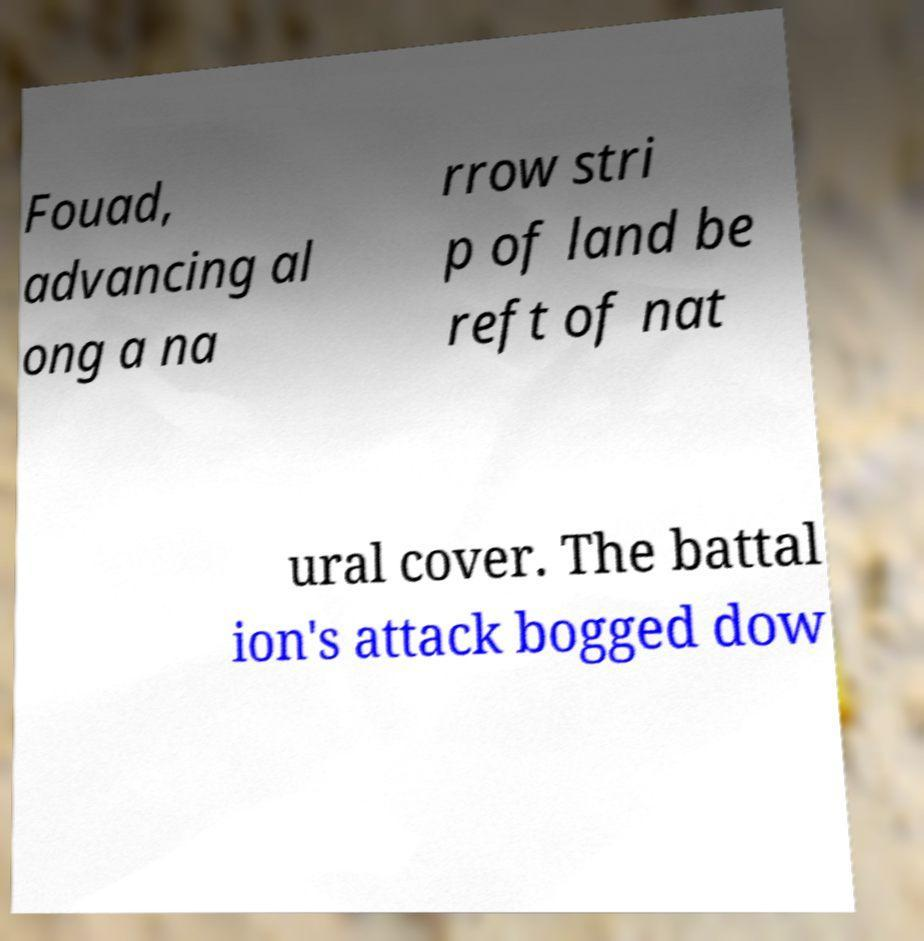Could you extract and type out the text from this image? Fouad, advancing al ong a na rrow stri p of land be reft of nat ural cover. The battal ion's attack bogged dow 